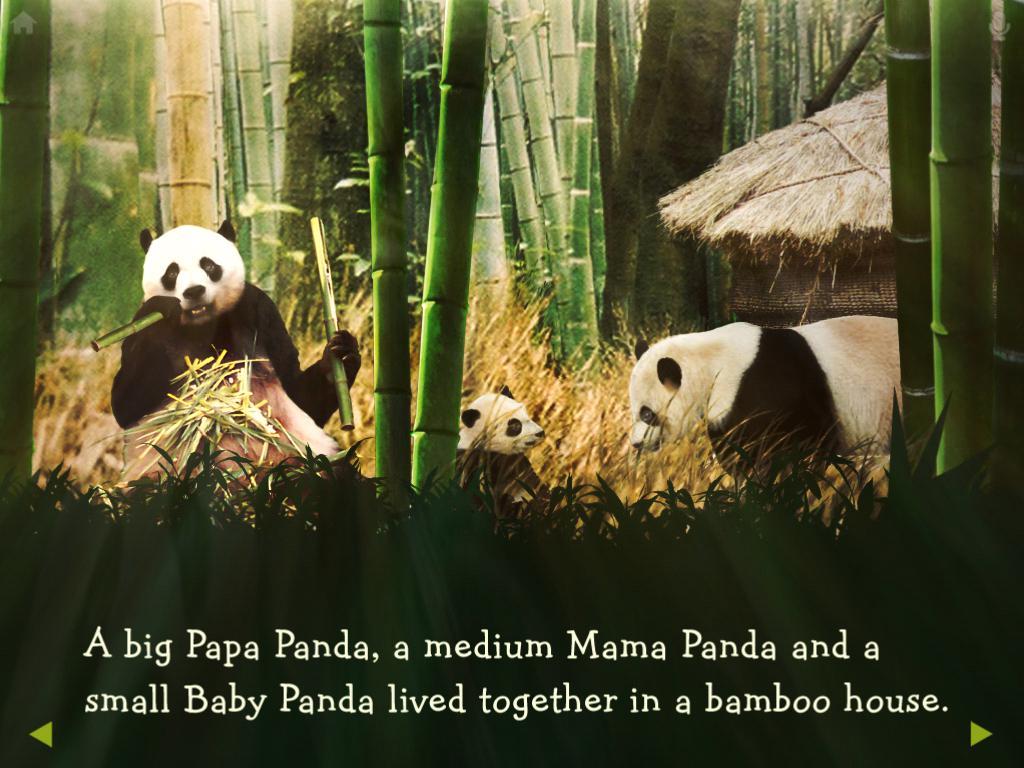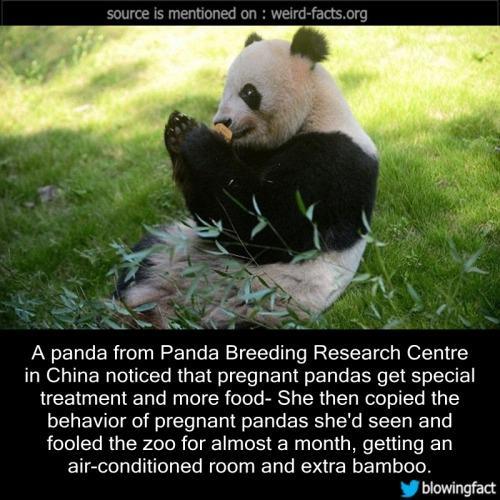The first image is the image on the left, the second image is the image on the right. Given the left and right images, does the statement "There is no more than one panda in the right image." hold true? Answer yes or no. Yes. The first image is the image on the left, the second image is the image on the right. For the images shown, is this caption "Six pandas are sitting outside." true? Answer yes or no. No. 